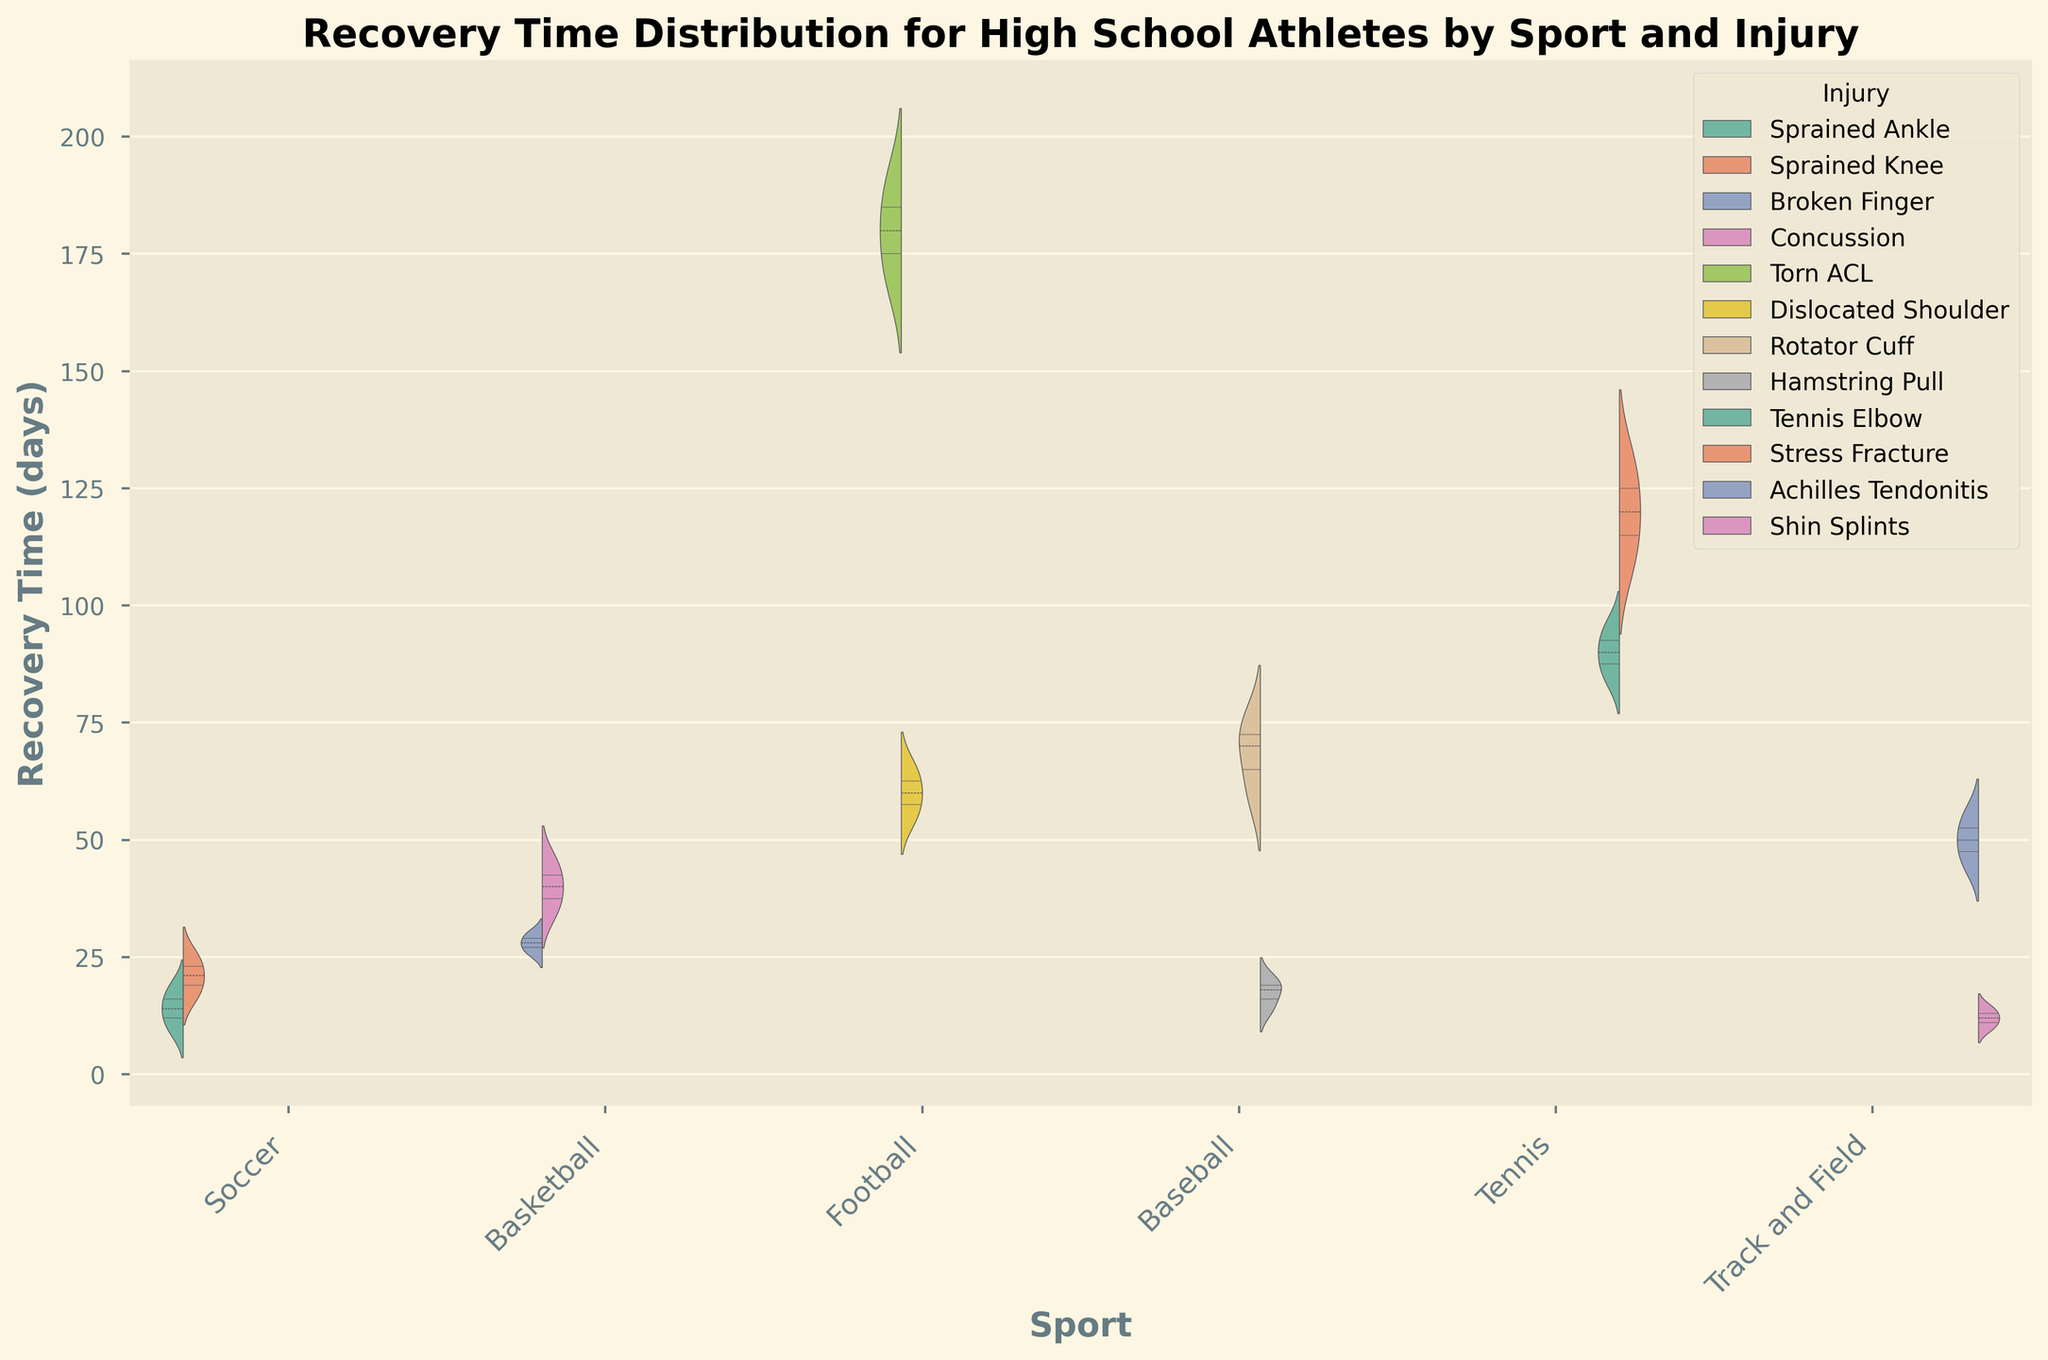Which sport has the longest average recovery time for a specific injury? To determine this, observe the median lines within each violin for each sport-injury pair and compare them. The sport with the highest median line has the longest average recovery time.
Answer: Football (Torn ACL) For which injury in Basketball is the recovery time more variable? Look at the spread of the shapes within the Basketball section. The injury with the wider spread indicates more variability in recovery times.
Answer: Concussion Which sport has the shortest recovery time for its injuries on average? Compare the heights of the violins for each sport. The sport with the generally lowest violins indicates the shortest recovery times on average.
Answer: Track and Field Between Rotator Cuff injury in Baseball and Dislocated Shoulder in Football, which has a longer recovery time? Compare the heights of the violins for these two specific injuries. The higher violin represents the longer recovery time.
Answer: Dislocated Shoulder (Football) What is the difference in median recovery time between a Sprained Ankle in Soccer and a Sprained Knee in Soccer? Locate the median lines for these two injuries within the Soccer section and calculate the difference in their heights.
Answer: 7 days How does the median recovery time for Shin Splints in Track and Field compare to a Hamstring Pull in Baseball? Compare the median lines for these two specific injuries and see which is higher or if they are approximately the same.
Answer: Hamstring Pull in Baseball is slightly longer What percentage of sports have at least one injury with a recovery time of 30 days or more? Identify the sports with at least one violin plot extending to or beyond the 30-day mark, then calculate the ratio of these sports to the total number of sports and convert it into a percentage. There are 6 sports in total.
Answer: 83.33% (5 out of 6) Is the recovery time for Tennis Elbow in Tennis generally longer or shorter than the recovery time for Shin Splints in Track and Field? Compare the heights of the violins for these injuries. The higher violin indicates a generally longer recovery time.
Answer: Longer 